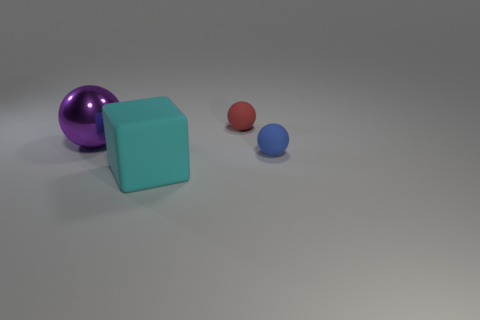Are the blue thing and the big thing that is on the right side of the purple metal thing made of the same material?
Ensure brevity in your answer.  Yes. How many objects are large shiny things to the left of the small red ball or small brown rubber objects?
Make the answer very short. 1. What is the shape of the object that is both right of the purple shiny thing and behind the small blue thing?
Provide a succinct answer. Sphere. What is the size of the cyan thing that is the same material as the small red object?
Make the answer very short. Large. How many things are either balls that are to the right of the red object or objects on the right side of the small red matte ball?
Your answer should be compact. 1. Is the size of the object that is left of the cyan rubber object the same as the cyan block?
Provide a short and direct response. Yes. There is a thing that is behind the purple metallic thing; what is its color?
Ensure brevity in your answer.  Red. There is a big thing that is the same shape as the tiny red object; what is its color?
Offer a very short reply. Purple. What number of small blue rubber things are to the left of the rubber object behind the big object left of the cyan cube?
Offer a very short reply. 0. Are there any other things that have the same material as the purple object?
Your response must be concise. No. 